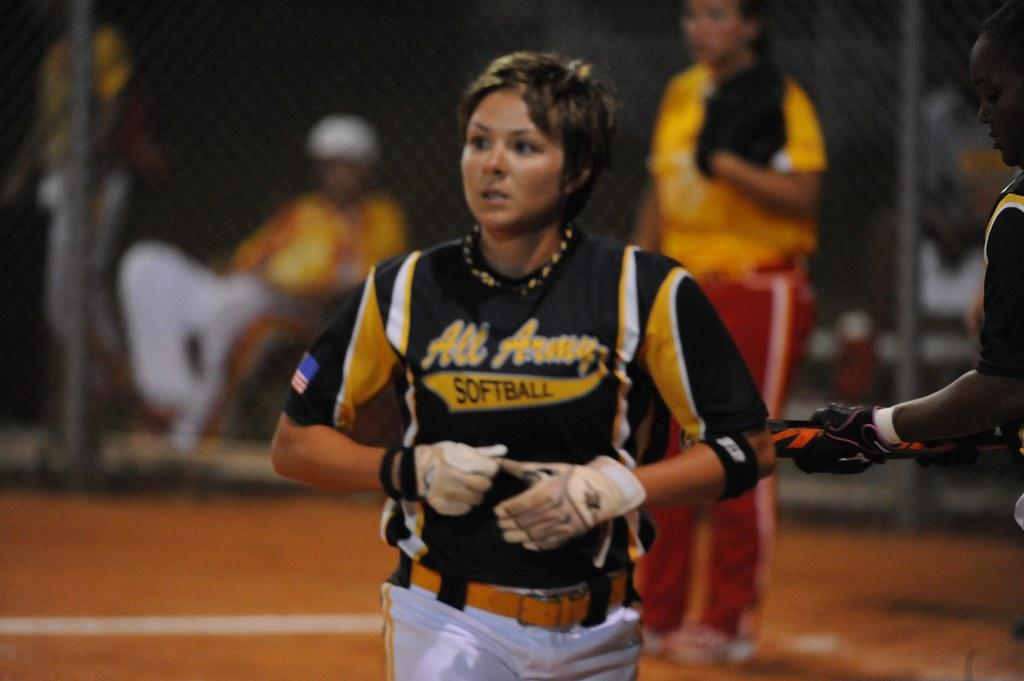<image>
Create a compact narrative representing the image presented. A woman on the All Army softball team runs to a base. 